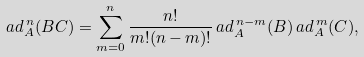<formula> <loc_0><loc_0><loc_500><loc_500>a d _ { A } ^ { \, n } ( B C ) = \sum _ { m = 0 } ^ { n } \frac { n ! } { m ! ( n - m ) ! } \, a d _ { A } ^ { \, n - m } ( B ) \, a d _ { A } ^ { \, m } ( C ) ,</formula> 